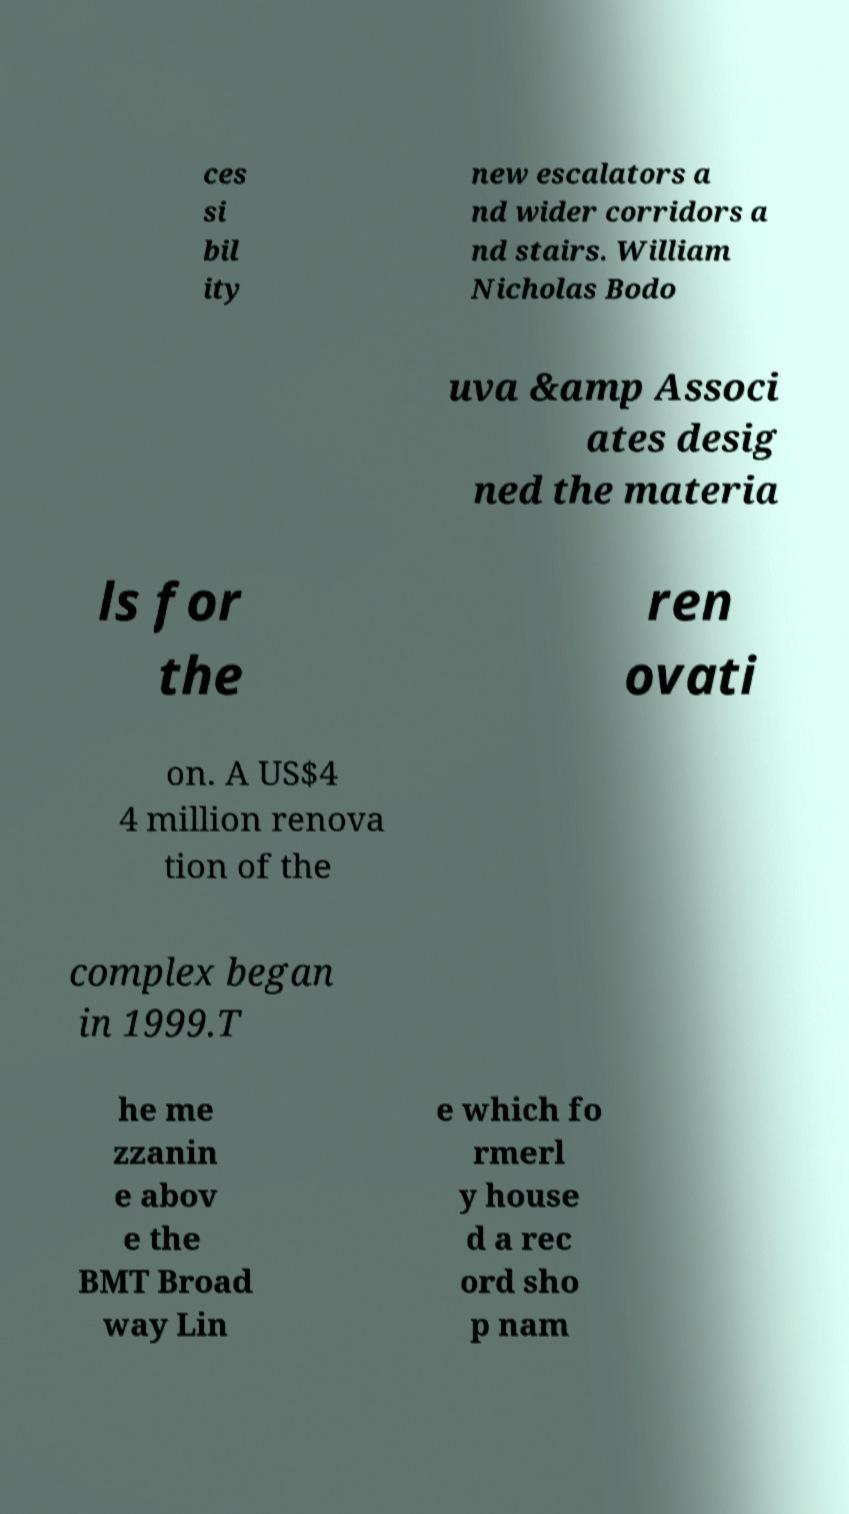What messages or text are displayed in this image? I need them in a readable, typed format. ces si bil ity new escalators a nd wider corridors a nd stairs. William Nicholas Bodo uva &amp Associ ates desig ned the materia ls for the ren ovati on. A US$4 4 million renova tion of the complex began in 1999.T he me zzanin e abov e the BMT Broad way Lin e which fo rmerl y house d a rec ord sho p nam 